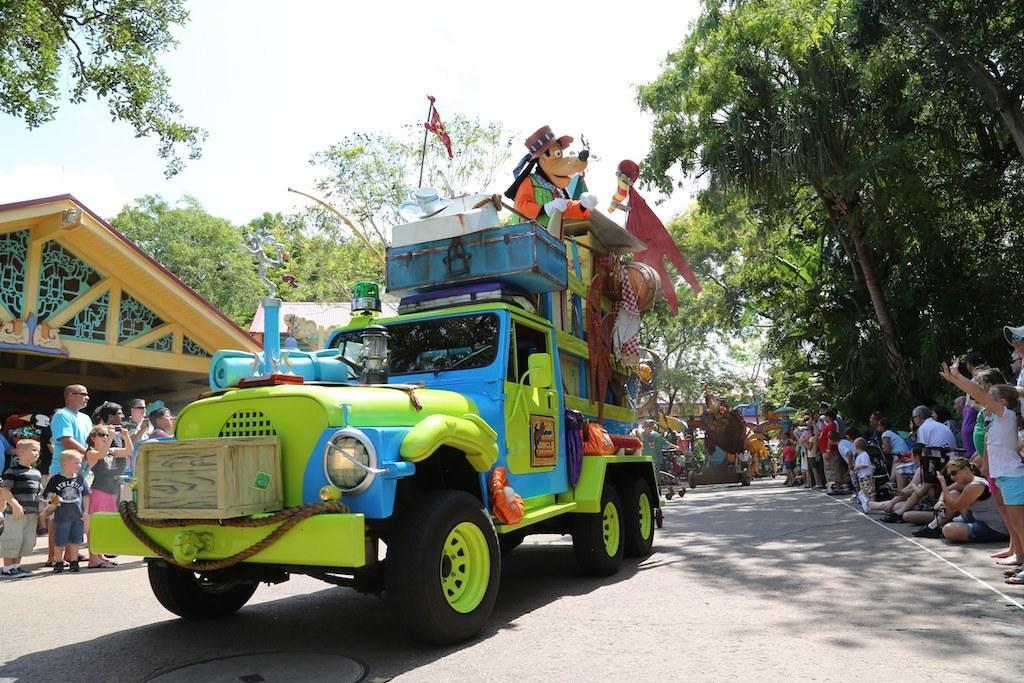Can you describe this image briefly? In this image there is a vehicle which is green in colour in the center. In the background there are trees and there are persons. On the right side there are persons sitting and standing and there are trees. On the left side there is a building and in front of the building there are persons standing in the sky is cloudy. 